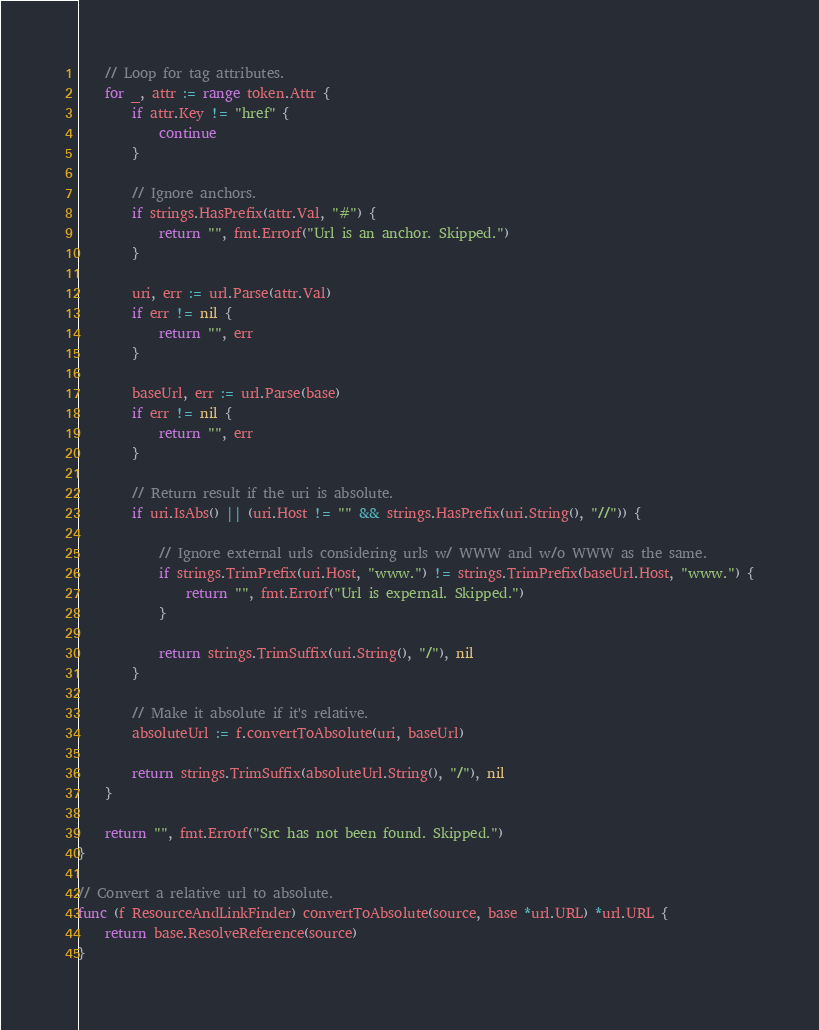<code> <loc_0><loc_0><loc_500><loc_500><_Go_>	// Loop for tag attributes.
	for _, attr := range token.Attr {
		if attr.Key != "href" {
			continue
		}

		// Ignore anchors.
		if strings.HasPrefix(attr.Val, "#") {
			return "", fmt.Errorf("Url is an anchor. Skipped.")
		}

		uri, err := url.Parse(attr.Val)
		if err != nil {
			return "", err
		}

		baseUrl, err := url.Parse(base)
		if err != nil {
			return "", err
		}

		// Return result if the uri is absolute.
		if uri.IsAbs() || (uri.Host != "" && strings.HasPrefix(uri.String(), "//")) {

			// Ignore external urls considering urls w/ WWW and w/o WWW as the same.
			if strings.TrimPrefix(uri.Host, "www.") != strings.TrimPrefix(baseUrl.Host, "www.") {
				return "", fmt.Errorf("Url is expernal. Skipped.")
			}

			return strings.TrimSuffix(uri.String(), "/"), nil
		}

		// Make it absolute if it's relative.
		absoluteUrl := f.convertToAbsolute(uri, baseUrl)

		return strings.TrimSuffix(absoluteUrl.String(), "/"), nil
	}

	return "", fmt.Errorf("Src has not been found. Skipped.")
}

// Convert a relative url to absolute.
func (f ResourceAndLinkFinder) convertToAbsolute(source, base *url.URL) *url.URL {
	return base.ResolveReference(source)
}
</code> 